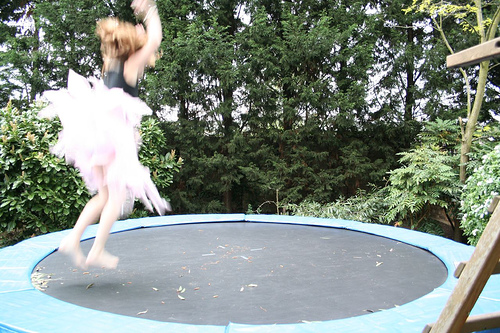What time of day does it seem to be? Given the natural light without harsh shadows and the serene appearance of the garden in the background, it suggests either early morning or late afternoon, times when the sunlight is softer. Does the setting look private or public? The setting appears to be a private backyard with a tranquil garden. The presence of the trampoline and the natural environment suggest a personal space. 